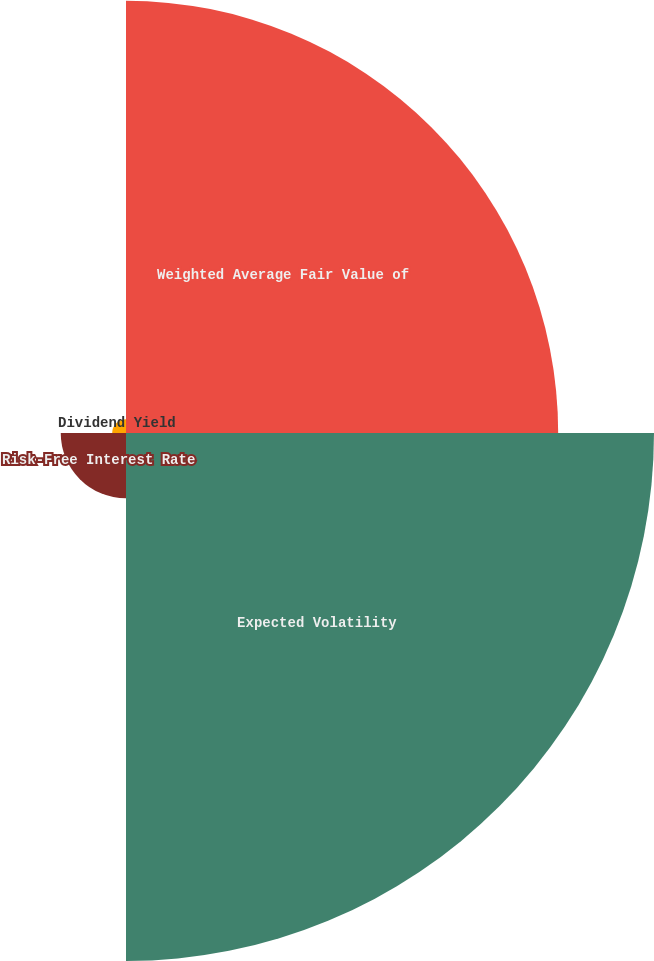Convert chart. <chart><loc_0><loc_0><loc_500><loc_500><pie_chart><fcel>Weighted Average Fair Value of<fcel>Expected Volatility<fcel>Risk-Free Interest Rate<fcel>Dividend Yield<nl><fcel>41.59%<fcel>50.81%<fcel>6.28%<fcel>1.33%<nl></chart> 